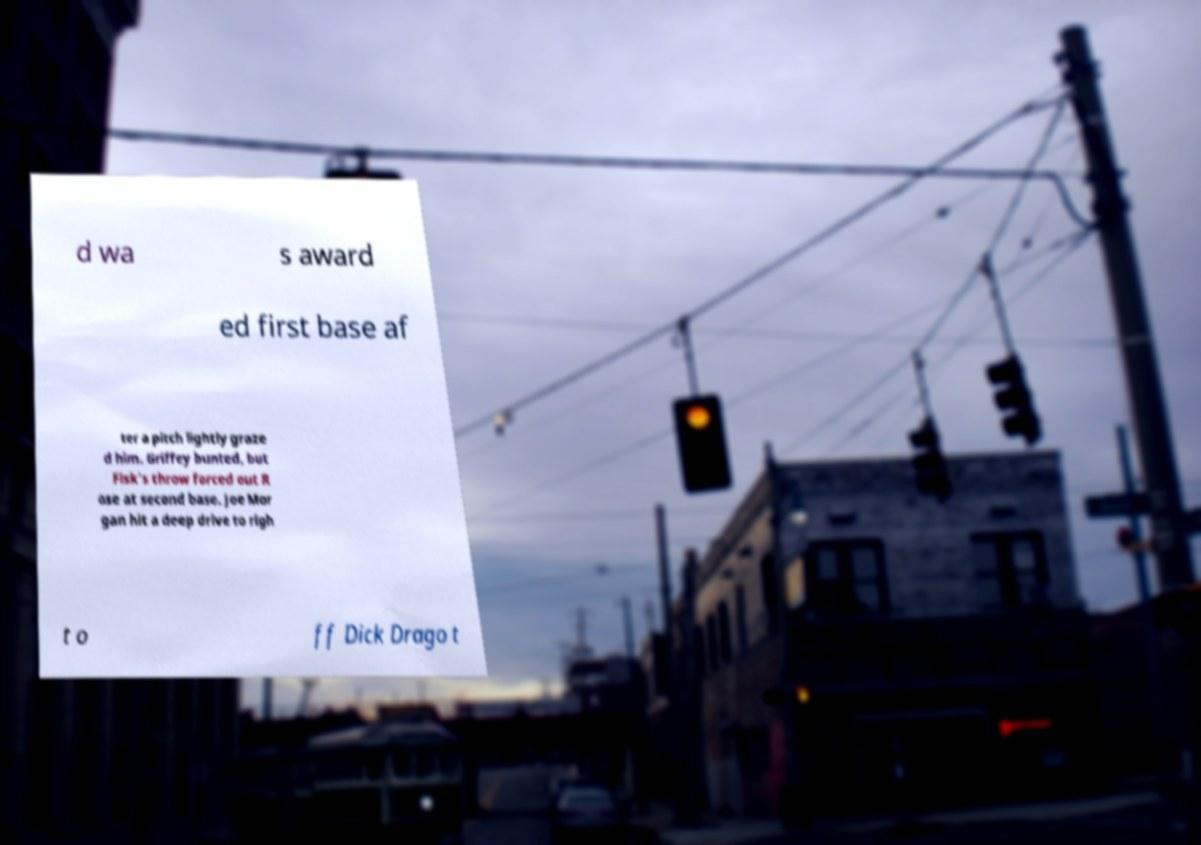For documentation purposes, I need the text within this image transcribed. Could you provide that? d wa s award ed first base af ter a pitch lightly graze d him. Griffey bunted, but Fisk's throw forced out R ose at second base. Joe Mor gan hit a deep drive to righ t o ff Dick Drago t 